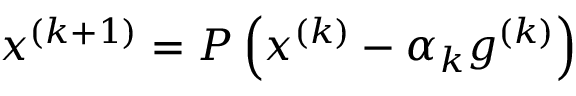Convert formula to latex. <formula><loc_0><loc_0><loc_500><loc_500>x ^ { ( k + 1 ) } = P \left ( x ^ { ( k ) } - \alpha _ { k } g ^ { ( k ) } \right )</formula> 